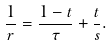<formula> <loc_0><loc_0><loc_500><loc_500>\frac { 1 } { r } = \frac { 1 - t } { \tau } + \frac { t } { s } .</formula> 